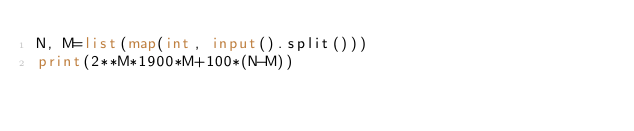<code> <loc_0><loc_0><loc_500><loc_500><_Python_>N, M=list(map(int, input().split()))
print(2**M*1900*M+100*(N-M))
</code> 